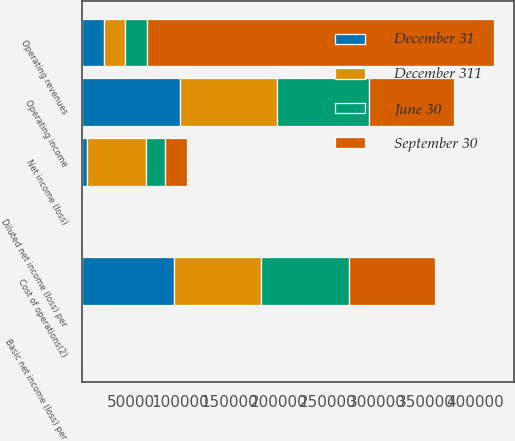<chart> <loc_0><loc_0><loc_500><loc_500><stacked_bar_chart><ecel><fcel>Operating revenues<fcel>Cost of operations(2)<fcel>Operating income<fcel>Net income (loss)<fcel>Basic net income (loss) per<fcel>Diluted net income (loss) per<nl><fcel>September 30<fcel>352474<fcel>87283<fcel>86110<fcel>22228<fcel>0.05<fcel>0.05<nl><fcel>June 30<fcel>22228<fcel>90042<fcel>93296<fcel>19991<fcel>0.05<fcel>0.05<nl><fcel>December 311<fcel>22228<fcel>88777<fcel>98491<fcel>59628<fcel>0.15<fcel>0.14<nl><fcel>December 31<fcel>22228<fcel>93520<fcel>100466<fcel>5549<fcel>0.01<fcel>0.01<nl></chart> 